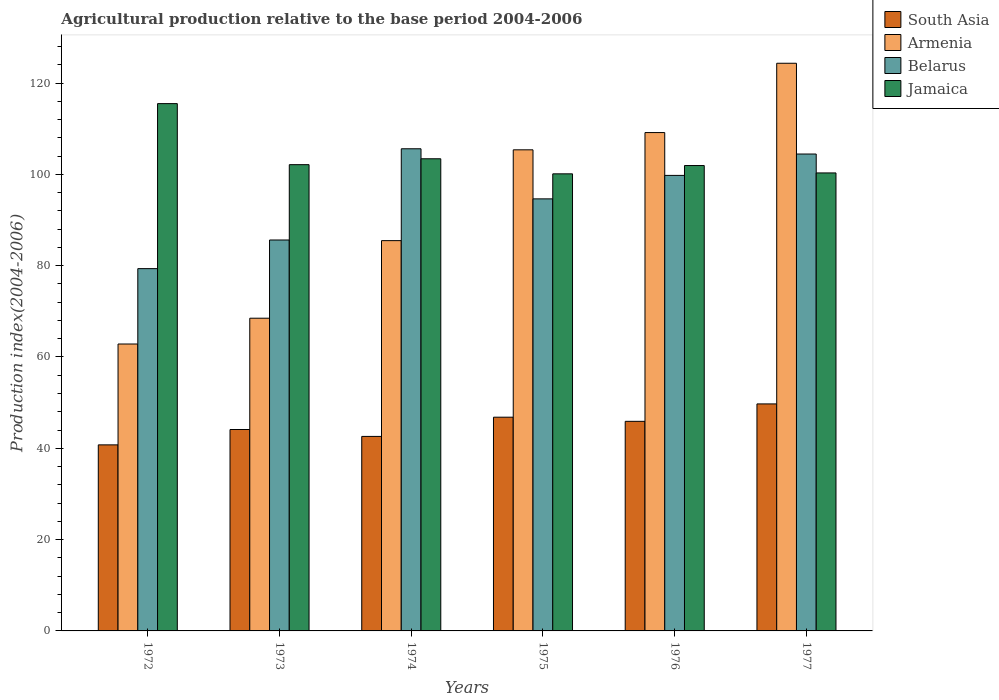How many groups of bars are there?
Offer a terse response. 6. Are the number of bars on each tick of the X-axis equal?
Provide a short and direct response. Yes. How many bars are there on the 3rd tick from the left?
Ensure brevity in your answer.  4. What is the label of the 4th group of bars from the left?
Offer a terse response. 1975. In how many cases, is the number of bars for a given year not equal to the number of legend labels?
Your answer should be compact. 0. What is the agricultural production index in South Asia in 1976?
Provide a short and direct response. 45.9. Across all years, what is the maximum agricultural production index in Belarus?
Offer a terse response. 105.6. Across all years, what is the minimum agricultural production index in Belarus?
Your answer should be very brief. 79.35. In which year was the agricultural production index in Armenia minimum?
Offer a terse response. 1972. What is the total agricultural production index in Belarus in the graph?
Offer a terse response. 569.42. What is the difference between the agricultural production index in Jamaica in 1974 and that in 1975?
Your response must be concise. 3.3. What is the difference between the agricultural production index in Belarus in 1975 and the agricultural production index in Armenia in 1977?
Offer a very short reply. -29.7. What is the average agricultural production index in South Asia per year?
Keep it short and to the point. 44.98. In the year 1977, what is the difference between the agricultural production index in Armenia and agricultural production index in South Asia?
Offer a very short reply. 74.61. In how many years, is the agricultural production index in South Asia greater than 92?
Ensure brevity in your answer.  0. What is the ratio of the agricultural production index in South Asia in 1974 to that in 1975?
Offer a terse response. 0.91. Is the agricultural production index in Belarus in 1972 less than that in 1976?
Provide a short and direct response. Yes. Is the difference between the agricultural production index in Armenia in 1974 and 1976 greater than the difference between the agricultural production index in South Asia in 1974 and 1976?
Provide a succinct answer. No. What is the difference between the highest and the second highest agricultural production index in Armenia?
Your answer should be compact. 15.18. What is the difference between the highest and the lowest agricultural production index in Jamaica?
Offer a very short reply. 15.38. In how many years, is the agricultural production index in Belarus greater than the average agricultural production index in Belarus taken over all years?
Keep it short and to the point. 3. Is the sum of the agricultural production index in Jamaica in 1976 and 1977 greater than the maximum agricultural production index in Armenia across all years?
Your answer should be compact. Yes. What does the 2nd bar from the left in 1972 represents?
Make the answer very short. Armenia. What does the 4th bar from the right in 1976 represents?
Make the answer very short. South Asia. Are all the bars in the graph horizontal?
Your response must be concise. No. Does the graph contain any zero values?
Your response must be concise. No. How many legend labels are there?
Give a very brief answer. 4. What is the title of the graph?
Ensure brevity in your answer.  Agricultural production relative to the base period 2004-2006. Does "Albania" appear as one of the legend labels in the graph?
Your response must be concise. No. What is the label or title of the X-axis?
Make the answer very short. Years. What is the label or title of the Y-axis?
Make the answer very short. Production index(2004-2006). What is the Production index(2004-2006) of South Asia in 1972?
Provide a succinct answer. 40.75. What is the Production index(2004-2006) of Armenia in 1972?
Provide a short and direct response. 62.84. What is the Production index(2004-2006) in Belarus in 1972?
Give a very brief answer. 79.35. What is the Production index(2004-2006) in Jamaica in 1972?
Your answer should be compact. 115.49. What is the Production index(2004-2006) in South Asia in 1973?
Offer a terse response. 44.12. What is the Production index(2004-2006) in Armenia in 1973?
Offer a terse response. 68.49. What is the Production index(2004-2006) of Belarus in 1973?
Keep it short and to the point. 85.62. What is the Production index(2004-2006) in Jamaica in 1973?
Keep it short and to the point. 102.12. What is the Production index(2004-2006) in South Asia in 1974?
Your answer should be very brief. 42.6. What is the Production index(2004-2006) in Armenia in 1974?
Your answer should be compact. 85.48. What is the Production index(2004-2006) in Belarus in 1974?
Offer a very short reply. 105.6. What is the Production index(2004-2006) of Jamaica in 1974?
Your response must be concise. 103.41. What is the Production index(2004-2006) in South Asia in 1975?
Offer a very short reply. 46.81. What is the Production index(2004-2006) of Armenia in 1975?
Offer a very short reply. 105.37. What is the Production index(2004-2006) in Belarus in 1975?
Give a very brief answer. 94.63. What is the Production index(2004-2006) of Jamaica in 1975?
Your answer should be very brief. 100.11. What is the Production index(2004-2006) of South Asia in 1976?
Your response must be concise. 45.9. What is the Production index(2004-2006) of Armenia in 1976?
Your answer should be very brief. 109.15. What is the Production index(2004-2006) in Belarus in 1976?
Your answer should be very brief. 99.77. What is the Production index(2004-2006) of Jamaica in 1976?
Your answer should be very brief. 101.93. What is the Production index(2004-2006) in South Asia in 1977?
Provide a succinct answer. 49.72. What is the Production index(2004-2006) in Armenia in 1977?
Give a very brief answer. 124.33. What is the Production index(2004-2006) of Belarus in 1977?
Your response must be concise. 104.45. What is the Production index(2004-2006) of Jamaica in 1977?
Your response must be concise. 100.31. Across all years, what is the maximum Production index(2004-2006) in South Asia?
Your answer should be very brief. 49.72. Across all years, what is the maximum Production index(2004-2006) in Armenia?
Make the answer very short. 124.33. Across all years, what is the maximum Production index(2004-2006) in Belarus?
Make the answer very short. 105.6. Across all years, what is the maximum Production index(2004-2006) of Jamaica?
Provide a short and direct response. 115.49. Across all years, what is the minimum Production index(2004-2006) of South Asia?
Make the answer very short. 40.75. Across all years, what is the minimum Production index(2004-2006) in Armenia?
Offer a terse response. 62.84. Across all years, what is the minimum Production index(2004-2006) in Belarus?
Keep it short and to the point. 79.35. Across all years, what is the minimum Production index(2004-2006) in Jamaica?
Keep it short and to the point. 100.11. What is the total Production index(2004-2006) of South Asia in the graph?
Your response must be concise. 269.9. What is the total Production index(2004-2006) in Armenia in the graph?
Your answer should be very brief. 555.66. What is the total Production index(2004-2006) of Belarus in the graph?
Offer a very short reply. 569.42. What is the total Production index(2004-2006) of Jamaica in the graph?
Your answer should be compact. 623.37. What is the difference between the Production index(2004-2006) of South Asia in 1972 and that in 1973?
Provide a short and direct response. -3.37. What is the difference between the Production index(2004-2006) of Armenia in 1972 and that in 1973?
Provide a succinct answer. -5.65. What is the difference between the Production index(2004-2006) of Belarus in 1972 and that in 1973?
Keep it short and to the point. -6.27. What is the difference between the Production index(2004-2006) of Jamaica in 1972 and that in 1973?
Your response must be concise. 13.37. What is the difference between the Production index(2004-2006) in South Asia in 1972 and that in 1974?
Provide a short and direct response. -1.85. What is the difference between the Production index(2004-2006) of Armenia in 1972 and that in 1974?
Give a very brief answer. -22.64. What is the difference between the Production index(2004-2006) of Belarus in 1972 and that in 1974?
Your answer should be very brief. -26.25. What is the difference between the Production index(2004-2006) of Jamaica in 1972 and that in 1974?
Offer a terse response. 12.08. What is the difference between the Production index(2004-2006) of South Asia in 1972 and that in 1975?
Provide a short and direct response. -6.06. What is the difference between the Production index(2004-2006) in Armenia in 1972 and that in 1975?
Keep it short and to the point. -42.53. What is the difference between the Production index(2004-2006) in Belarus in 1972 and that in 1975?
Your response must be concise. -15.28. What is the difference between the Production index(2004-2006) of Jamaica in 1972 and that in 1975?
Your answer should be compact. 15.38. What is the difference between the Production index(2004-2006) in South Asia in 1972 and that in 1976?
Provide a short and direct response. -5.15. What is the difference between the Production index(2004-2006) of Armenia in 1972 and that in 1976?
Provide a succinct answer. -46.31. What is the difference between the Production index(2004-2006) in Belarus in 1972 and that in 1976?
Provide a short and direct response. -20.42. What is the difference between the Production index(2004-2006) of Jamaica in 1972 and that in 1976?
Your response must be concise. 13.56. What is the difference between the Production index(2004-2006) in South Asia in 1972 and that in 1977?
Provide a short and direct response. -8.97. What is the difference between the Production index(2004-2006) in Armenia in 1972 and that in 1977?
Provide a succinct answer. -61.49. What is the difference between the Production index(2004-2006) of Belarus in 1972 and that in 1977?
Your answer should be compact. -25.1. What is the difference between the Production index(2004-2006) in Jamaica in 1972 and that in 1977?
Ensure brevity in your answer.  15.18. What is the difference between the Production index(2004-2006) of South Asia in 1973 and that in 1974?
Your response must be concise. 1.51. What is the difference between the Production index(2004-2006) in Armenia in 1973 and that in 1974?
Your response must be concise. -16.99. What is the difference between the Production index(2004-2006) of Belarus in 1973 and that in 1974?
Keep it short and to the point. -19.98. What is the difference between the Production index(2004-2006) in Jamaica in 1973 and that in 1974?
Make the answer very short. -1.29. What is the difference between the Production index(2004-2006) of South Asia in 1973 and that in 1975?
Keep it short and to the point. -2.69. What is the difference between the Production index(2004-2006) of Armenia in 1973 and that in 1975?
Your answer should be compact. -36.88. What is the difference between the Production index(2004-2006) in Belarus in 1973 and that in 1975?
Provide a succinct answer. -9.01. What is the difference between the Production index(2004-2006) of Jamaica in 1973 and that in 1975?
Provide a short and direct response. 2.01. What is the difference between the Production index(2004-2006) in South Asia in 1973 and that in 1976?
Provide a succinct answer. -1.79. What is the difference between the Production index(2004-2006) in Armenia in 1973 and that in 1976?
Provide a succinct answer. -40.66. What is the difference between the Production index(2004-2006) of Belarus in 1973 and that in 1976?
Offer a very short reply. -14.15. What is the difference between the Production index(2004-2006) in Jamaica in 1973 and that in 1976?
Your answer should be very brief. 0.19. What is the difference between the Production index(2004-2006) of South Asia in 1973 and that in 1977?
Provide a succinct answer. -5.6. What is the difference between the Production index(2004-2006) in Armenia in 1973 and that in 1977?
Provide a succinct answer. -55.84. What is the difference between the Production index(2004-2006) of Belarus in 1973 and that in 1977?
Offer a terse response. -18.83. What is the difference between the Production index(2004-2006) in Jamaica in 1973 and that in 1977?
Provide a succinct answer. 1.81. What is the difference between the Production index(2004-2006) of South Asia in 1974 and that in 1975?
Ensure brevity in your answer.  -4.21. What is the difference between the Production index(2004-2006) of Armenia in 1974 and that in 1975?
Offer a terse response. -19.89. What is the difference between the Production index(2004-2006) in Belarus in 1974 and that in 1975?
Offer a very short reply. 10.97. What is the difference between the Production index(2004-2006) in South Asia in 1974 and that in 1976?
Ensure brevity in your answer.  -3.3. What is the difference between the Production index(2004-2006) of Armenia in 1974 and that in 1976?
Provide a succinct answer. -23.67. What is the difference between the Production index(2004-2006) of Belarus in 1974 and that in 1976?
Offer a very short reply. 5.83. What is the difference between the Production index(2004-2006) in Jamaica in 1974 and that in 1976?
Provide a short and direct response. 1.48. What is the difference between the Production index(2004-2006) of South Asia in 1974 and that in 1977?
Offer a terse response. -7.12. What is the difference between the Production index(2004-2006) in Armenia in 1974 and that in 1977?
Provide a succinct answer. -38.85. What is the difference between the Production index(2004-2006) in Belarus in 1974 and that in 1977?
Offer a terse response. 1.15. What is the difference between the Production index(2004-2006) in Jamaica in 1974 and that in 1977?
Your response must be concise. 3.1. What is the difference between the Production index(2004-2006) in South Asia in 1975 and that in 1976?
Your response must be concise. 0.91. What is the difference between the Production index(2004-2006) of Armenia in 1975 and that in 1976?
Keep it short and to the point. -3.78. What is the difference between the Production index(2004-2006) in Belarus in 1975 and that in 1976?
Keep it short and to the point. -5.14. What is the difference between the Production index(2004-2006) in Jamaica in 1975 and that in 1976?
Give a very brief answer. -1.82. What is the difference between the Production index(2004-2006) in South Asia in 1975 and that in 1977?
Provide a succinct answer. -2.91. What is the difference between the Production index(2004-2006) in Armenia in 1975 and that in 1977?
Ensure brevity in your answer.  -18.96. What is the difference between the Production index(2004-2006) of Belarus in 1975 and that in 1977?
Your answer should be compact. -9.82. What is the difference between the Production index(2004-2006) of Jamaica in 1975 and that in 1977?
Offer a terse response. -0.2. What is the difference between the Production index(2004-2006) in South Asia in 1976 and that in 1977?
Make the answer very short. -3.82. What is the difference between the Production index(2004-2006) of Armenia in 1976 and that in 1977?
Provide a short and direct response. -15.18. What is the difference between the Production index(2004-2006) in Belarus in 1976 and that in 1977?
Provide a succinct answer. -4.68. What is the difference between the Production index(2004-2006) in Jamaica in 1976 and that in 1977?
Offer a terse response. 1.62. What is the difference between the Production index(2004-2006) of South Asia in 1972 and the Production index(2004-2006) of Armenia in 1973?
Provide a short and direct response. -27.74. What is the difference between the Production index(2004-2006) in South Asia in 1972 and the Production index(2004-2006) in Belarus in 1973?
Make the answer very short. -44.87. What is the difference between the Production index(2004-2006) of South Asia in 1972 and the Production index(2004-2006) of Jamaica in 1973?
Your answer should be compact. -61.37. What is the difference between the Production index(2004-2006) in Armenia in 1972 and the Production index(2004-2006) in Belarus in 1973?
Ensure brevity in your answer.  -22.78. What is the difference between the Production index(2004-2006) in Armenia in 1972 and the Production index(2004-2006) in Jamaica in 1973?
Ensure brevity in your answer.  -39.28. What is the difference between the Production index(2004-2006) in Belarus in 1972 and the Production index(2004-2006) in Jamaica in 1973?
Keep it short and to the point. -22.77. What is the difference between the Production index(2004-2006) of South Asia in 1972 and the Production index(2004-2006) of Armenia in 1974?
Your answer should be very brief. -44.73. What is the difference between the Production index(2004-2006) of South Asia in 1972 and the Production index(2004-2006) of Belarus in 1974?
Your answer should be very brief. -64.85. What is the difference between the Production index(2004-2006) of South Asia in 1972 and the Production index(2004-2006) of Jamaica in 1974?
Your response must be concise. -62.66. What is the difference between the Production index(2004-2006) of Armenia in 1972 and the Production index(2004-2006) of Belarus in 1974?
Offer a terse response. -42.76. What is the difference between the Production index(2004-2006) in Armenia in 1972 and the Production index(2004-2006) in Jamaica in 1974?
Offer a terse response. -40.57. What is the difference between the Production index(2004-2006) of Belarus in 1972 and the Production index(2004-2006) of Jamaica in 1974?
Offer a very short reply. -24.06. What is the difference between the Production index(2004-2006) in South Asia in 1972 and the Production index(2004-2006) in Armenia in 1975?
Your answer should be very brief. -64.62. What is the difference between the Production index(2004-2006) in South Asia in 1972 and the Production index(2004-2006) in Belarus in 1975?
Keep it short and to the point. -53.88. What is the difference between the Production index(2004-2006) in South Asia in 1972 and the Production index(2004-2006) in Jamaica in 1975?
Offer a very short reply. -59.36. What is the difference between the Production index(2004-2006) of Armenia in 1972 and the Production index(2004-2006) of Belarus in 1975?
Provide a succinct answer. -31.79. What is the difference between the Production index(2004-2006) of Armenia in 1972 and the Production index(2004-2006) of Jamaica in 1975?
Provide a short and direct response. -37.27. What is the difference between the Production index(2004-2006) in Belarus in 1972 and the Production index(2004-2006) in Jamaica in 1975?
Provide a succinct answer. -20.76. What is the difference between the Production index(2004-2006) in South Asia in 1972 and the Production index(2004-2006) in Armenia in 1976?
Your response must be concise. -68.4. What is the difference between the Production index(2004-2006) in South Asia in 1972 and the Production index(2004-2006) in Belarus in 1976?
Give a very brief answer. -59.02. What is the difference between the Production index(2004-2006) of South Asia in 1972 and the Production index(2004-2006) of Jamaica in 1976?
Offer a very short reply. -61.18. What is the difference between the Production index(2004-2006) in Armenia in 1972 and the Production index(2004-2006) in Belarus in 1976?
Offer a very short reply. -36.93. What is the difference between the Production index(2004-2006) in Armenia in 1972 and the Production index(2004-2006) in Jamaica in 1976?
Offer a terse response. -39.09. What is the difference between the Production index(2004-2006) of Belarus in 1972 and the Production index(2004-2006) of Jamaica in 1976?
Make the answer very short. -22.58. What is the difference between the Production index(2004-2006) of South Asia in 1972 and the Production index(2004-2006) of Armenia in 1977?
Your answer should be compact. -83.58. What is the difference between the Production index(2004-2006) in South Asia in 1972 and the Production index(2004-2006) in Belarus in 1977?
Provide a succinct answer. -63.7. What is the difference between the Production index(2004-2006) of South Asia in 1972 and the Production index(2004-2006) of Jamaica in 1977?
Your answer should be very brief. -59.56. What is the difference between the Production index(2004-2006) of Armenia in 1972 and the Production index(2004-2006) of Belarus in 1977?
Make the answer very short. -41.61. What is the difference between the Production index(2004-2006) in Armenia in 1972 and the Production index(2004-2006) in Jamaica in 1977?
Make the answer very short. -37.47. What is the difference between the Production index(2004-2006) in Belarus in 1972 and the Production index(2004-2006) in Jamaica in 1977?
Your answer should be compact. -20.96. What is the difference between the Production index(2004-2006) of South Asia in 1973 and the Production index(2004-2006) of Armenia in 1974?
Offer a terse response. -41.36. What is the difference between the Production index(2004-2006) in South Asia in 1973 and the Production index(2004-2006) in Belarus in 1974?
Offer a very short reply. -61.48. What is the difference between the Production index(2004-2006) in South Asia in 1973 and the Production index(2004-2006) in Jamaica in 1974?
Ensure brevity in your answer.  -59.29. What is the difference between the Production index(2004-2006) of Armenia in 1973 and the Production index(2004-2006) of Belarus in 1974?
Offer a terse response. -37.11. What is the difference between the Production index(2004-2006) in Armenia in 1973 and the Production index(2004-2006) in Jamaica in 1974?
Your response must be concise. -34.92. What is the difference between the Production index(2004-2006) of Belarus in 1973 and the Production index(2004-2006) of Jamaica in 1974?
Keep it short and to the point. -17.79. What is the difference between the Production index(2004-2006) in South Asia in 1973 and the Production index(2004-2006) in Armenia in 1975?
Your answer should be compact. -61.25. What is the difference between the Production index(2004-2006) in South Asia in 1973 and the Production index(2004-2006) in Belarus in 1975?
Make the answer very short. -50.51. What is the difference between the Production index(2004-2006) of South Asia in 1973 and the Production index(2004-2006) of Jamaica in 1975?
Ensure brevity in your answer.  -55.99. What is the difference between the Production index(2004-2006) of Armenia in 1973 and the Production index(2004-2006) of Belarus in 1975?
Ensure brevity in your answer.  -26.14. What is the difference between the Production index(2004-2006) of Armenia in 1973 and the Production index(2004-2006) of Jamaica in 1975?
Offer a very short reply. -31.62. What is the difference between the Production index(2004-2006) of Belarus in 1973 and the Production index(2004-2006) of Jamaica in 1975?
Provide a short and direct response. -14.49. What is the difference between the Production index(2004-2006) in South Asia in 1973 and the Production index(2004-2006) in Armenia in 1976?
Make the answer very short. -65.03. What is the difference between the Production index(2004-2006) of South Asia in 1973 and the Production index(2004-2006) of Belarus in 1976?
Provide a short and direct response. -55.65. What is the difference between the Production index(2004-2006) in South Asia in 1973 and the Production index(2004-2006) in Jamaica in 1976?
Offer a very short reply. -57.81. What is the difference between the Production index(2004-2006) of Armenia in 1973 and the Production index(2004-2006) of Belarus in 1976?
Offer a terse response. -31.28. What is the difference between the Production index(2004-2006) in Armenia in 1973 and the Production index(2004-2006) in Jamaica in 1976?
Offer a very short reply. -33.44. What is the difference between the Production index(2004-2006) in Belarus in 1973 and the Production index(2004-2006) in Jamaica in 1976?
Your answer should be very brief. -16.31. What is the difference between the Production index(2004-2006) in South Asia in 1973 and the Production index(2004-2006) in Armenia in 1977?
Offer a terse response. -80.21. What is the difference between the Production index(2004-2006) in South Asia in 1973 and the Production index(2004-2006) in Belarus in 1977?
Your answer should be very brief. -60.33. What is the difference between the Production index(2004-2006) of South Asia in 1973 and the Production index(2004-2006) of Jamaica in 1977?
Provide a short and direct response. -56.19. What is the difference between the Production index(2004-2006) in Armenia in 1973 and the Production index(2004-2006) in Belarus in 1977?
Your answer should be compact. -35.96. What is the difference between the Production index(2004-2006) of Armenia in 1973 and the Production index(2004-2006) of Jamaica in 1977?
Keep it short and to the point. -31.82. What is the difference between the Production index(2004-2006) in Belarus in 1973 and the Production index(2004-2006) in Jamaica in 1977?
Your answer should be very brief. -14.69. What is the difference between the Production index(2004-2006) in South Asia in 1974 and the Production index(2004-2006) in Armenia in 1975?
Provide a succinct answer. -62.77. What is the difference between the Production index(2004-2006) in South Asia in 1974 and the Production index(2004-2006) in Belarus in 1975?
Keep it short and to the point. -52.03. What is the difference between the Production index(2004-2006) in South Asia in 1974 and the Production index(2004-2006) in Jamaica in 1975?
Keep it short and to the point. -57.51. What is the difference between the Production index(2004-2006) in Armenia in 1974 and the Production index(2004-2006) in Belarus in 1975?
Your answer should be compact. -9.15. What is the difference between the Production index(2004-2006) in Armenia in 1974 and the Production index(2004-2006) in Jamaica in 1975?
Offer a very short reply. -14.63. What is the difference between the Production index(2004-2006) in Belarus in 1974 and the Production index(2004-2006) in Jamaica in 1975?
Provide a short and direct response. 5.49. What is the difference between the Production index(2004-2006) of South Asia in 1974 and the Production index(2004-2006) of Armenia in 1976?
Offer a very short reply. -66.55. What is the difference between the Production index(2004-2006) in South Asia in 1974 and the Production index(2004-2006) in Belarus in 1976?
Your answer should be very brief. -57.17. What is the difference between the Production index(2004-2006) in South Asia in 1974 and the Production index(2004-2006) in Jamaica in 1976?
Your answer should be compact. -59.33. What is the difference between the Production index(2004-2006) in Armenia in 1974 and the Production index(2004-2006) in Belarus in 1976?
Offer a very short reply. -14.29. What is the difference between the Production index(2004-2006) of Armenia in 1974 and the Production index(2004-2006) of Jamaica in 1976?
Offer a terse response. -16.45. What is the difference between the Production index(2004-2006) in Belarus in 1974 and the Production index(2004-2006) in Jamaica in 1976?
Offer a terse response. 3.67. What is the difference between the Production index(2004-2006) in South Asia in 1974 and the Production index(2004-2006) in Armenia in 1977?
Your response must be concise. -81.73. What is the difference between the Production index(2004-2006) of South Asia in 1974 and the Production index(2004-2006) of Belarus in 1977?
Make the answer very short. -61.85. What is the difference between the Production index(2004-2006) of South Asia in 1974 and the Production index(2004-2006) of Jamaica in 1977?
Offer a very short reply. -57.71. What is the difference between the Production index(2004-2006) in Armenia in 1974 and the Production index(2004-2006) in Belarus in 1977?
Ensure brevity in your answer.  -18.97. What is the difference between the Production index(2004-2006) in Armenia in 1974 and the Production index(2004-2006) in Jamaica in 1977?
Offer a very short reply. -14.83. What is the difference between the Production index(2004-2006) of Belarus in 1974 and the Production index(2004-2006) of Jamaica in 1977?
Make the answer very short. 5.29. What is the difference between the Production index(2004-2006) of South Asia in 1975 and the Production index(2004-2006) of Armenia in 1976?
Offer a terse response. -62.34. What is the difference between the Production index(2004-2006) in South Asia in 1975 and the Production index(2004-2006) in Belarus in 1976?
Give a very brief answer. -52.96. What is the difference between the Production index(2004-2006) of South Asia in 1975 and the Production index(2004-2006) of Jamaica in 1976?
Your response must be concise. -55.12. What is the difference between the Production index(2004-2006) of Armenia in 1975 and the Production index(2004-2006) of Belarus in 1976?
Your answer should be very brief. 5.6. What is the difference between the Production index(2004-2006) of Armenia in 1975 and the Production index(2004-2006) of Jamaica in 1976?
Offer a very short reply. 3.44. What is the difference between the Production index(2004-2006) of Belarus in 1975 and the Production index(2004-2006) of Jamaica in 1976?
Keep it short and to the point. -7.3. What is the difference between the Production index(2004-2006) in South Asia in 1975 and the Production index(2004-2006) in Armenia in 1977?
Offer a terse response. -77.52. What is the difference between the Production index(2004-2006) in South Asia in 1975 and the Production index(2004-2006) in Belarus in 1977?
Make the answer very short. -57.64. What is the difference between the Production index(2004-2006) of South Asia in 1975 and the Production index(2004-2006) of Jamaica in 1977?
Provide a short and direct response. -53.5. What is the difference between the Production index(2004-2006) of Armenia in 1975 and the Production index(2004-2006) of Jamaica in 1977?
Your response must be concise. 5.06. What is the difference between the Production index(2004-2006) of Belarus in 1975 and the Production index(2004-2006) of Jamaica in 1977?
Offer a very short reply. -5.68. What is the difference between the Production index(2004-2006) in South Asia in 1976 and the Production index(2004-2006) in Armenia in 1977?
Provide a succinct answer. -78.43. What is the difference between the Production index(2004-2006) of South Asia in 1976 and the Production index(2004-2006) of Belarus in 1977?
Your answer should be very brief. -58.55. What is the difference between the Production index(2004-2006) of South Asia in 1976 and the Production index(2004-2006) of Jamaica in 1977?
Keep it short and to the point. -54.41. What is the difference between the Production index(2004-2006) of Armenia in 1976 and the Production index(2004-2006) of Belarus in 1977?
Make the answer very short. 4.7. What is the difference between the Production index(2004-2006) of Armenia in 1976 and the Production index(2004-2006) of Jamaica in 1977?
Offer a terse response. 8.84. What is the difference between the Production index(2004-2006) of Belarus in 1976 and the Production index(2004-2006) of Jamaica in 1977?
Make the answer very short. -0.54. What is the average Production index(2004-2006) in South Asia per year?
Keep it short and to the point. 44.98. What is the average Production index(2004-2006) in Armenia per year?
Give a very brief answer. 92.61. What is the average Production index(2004-2006) of Belarus per year?
Your response must be concise. 94.9. What is the average Production index(2004-2006) in Jamaica per year?
Keep it short and to the point. 103.89. In the year 1972, what is the difference between the Production index(2004-2006) in South Asia and Production index(2004-2006) in Armenia?
Provide a short and direct response. -22.09. In the year 1972, what is the difference between the Production index(2004-2006) in South Asia and Production index(2004-2006) in Belarus?
Your answer should be compact. -38.6. In the year 1972, what is the difference between the Production index(2004-2006) of South Asia and Production index(2004-2006) of Jamaica?
Offer a terse response. -74.74. In the year 1972, what is the difference between the Production index(2004-2006) of Armenia and Production index(2004-2006) of Belarus?
Your answer should be very brief. -16.51. In the year 1972, what is the difference between the Production index(2004-2006) in Armenia and Production index(2004-2006) in Jamaica?
Offer a very short reply. -52.65. In the year 1972, what is the difference between the Production index(2004-2006) in Belarus and Production index(2004-2006) in Jamaica?
Keep it short and to the point. -36.14. In the year 1973, what is the difference between the Production index(2004-2006) in South Asia and Production index(2004-2006) in Armenia?
Ensure brevity in your answer.  -24.37. In the year 1973, what is the difference between the Production index(2004-2006) in South Asia and Production index(2004-2006) in Belarus?
Give a very brief answer. -41.5. In the year 1973, what is the difference between the Production index(2004-2006) of South Asia and Production index(2004-2006) of Jamaica?
Make the answer very short. -58. In the year 1973, what is the difference between the Production index(2004-2006) of Armenia and Production index(2004-2006) of Belarus?
Your response must be concise. -17.13. In the year 1973, what is the difference between the Production index(2004-2006) of Armenia and Production index(2004-2006) of Jamaica?
Ensure brevity in your answer.  -33.63. In the year 1973, what is the difference between the Production index(2004-2006) of Belarus and Production index(2004-2006) of Jamaica?
Keep it short and to the point. -16.5. In the year 1974, what is the difference between the Production index(2004-2006) of South Asia and Production index(2004-2006) of Armenia?
Your answer should be very brief. -42.88. In the year 1974, what is the difference between the Production index(2004-2006) of South Asia and Production index(2004-2006) of Belarus?
Give a very brief answer. -63. In the year 1974, what is the difference between the Production index(2004-2006) of South Asia and Production index(2004-2006) of Jamaica?
Ensure brevity in your answer.  -60.81. In the year 1974, what is the difference between the Production index(2004-2006) of Armenia and Production index(2004-2006) of Belarus?
Ensure brevity in your answer.  -20.12. In the year 1974, what is the difference between the Production index(2004-2006) of Armenia and Production index(2004-2006) of Jamaica?
Keep it short and to the point. -17.93. In the year 1974, what is the difference between the Production index(2004-2006) of Belarus and Production index(2004-2006) of Jamaica?
Offer a terse response. 2.19. In the year 1975, what is the difference between the Production index(2004-2006) in South Asia and Production index(2004-2006) in Armenia?
Your response must be concise. -58.56. In the year 1975, what is the difference between the Production index(2004-2006) in South Asia and Production index(2004-2006) in Belarus?
Offer a very short reply. -47.82. In the year 1975, what is the difference between the Production index(2004-2006) in South Asia and Production index(2004-2006) in Jamaica?
Offer a very short reply. -53.3. In the year 1975, what is the difference between the Production index(2004-2006) of Armenia and Production index(2004-2006) of Belarus?
Your response must be concise. 10.74. In the year 1975, what is the difference between the Production index(2004-2006) of Armenia and Production index(2004-2006) of Jamaica?
Give a very brief answer. 5.26. In the year 1975, what is the difference between the Production index(2004-2006) of Belarus and Production index(2004-2006) of Jamaica?
Provide a short and direct response. -5.48. In the year 1976, what is the difference between the Production index(2004-2006) in South Asia and Production index(2004-2006) in Armenia?
Offer a very short reply. -63.25. In the year 1976, what is the difference between the Production index(2004-2006) in South Asia and Production index(2004-2006) in Belarus?
Make the answer very short. -53.87. In the year 1976, what is the difference between the Production index(2004-2006) in South Asia and Production index(2004-2006) in Jamaica?
Your response must be concise. -56.03. In the year 1976, what is the difference between the Production index(2004-2006) in Armenia and Production index(2004-2006) in Belarus?
Provide a succinct answer. 9.38. In the year 1976, what is the difference between the Production index(2004-2006) in Armenia and Production index(2004-2006) in Jamaica?
Provide a succinct answer. 7.22. In the year 1976, what is the difference between the Production index(2004-2006) of Belarus and Production index(2004-2006) of Jamaica?
Your answer should be very brief. -2.16. In the year 1977, what is the difference between the Production index(2004-2006) of South Asia and Production index(2004-2006) of Armenia?
Ensure brevity in your answer.  -74.61. In the year 1977, what is the difference between the Production index(2004-2006) in South Asia and Production index(2004-2006) in Belarus?
Make the answer very short. -54.73. In the year 1977, what is the difference between the Production index(2004-2006) of South Asia and Production index(2004-2006) of Jamaica?
Ensure brevity in your answer.  -50.59. In the year 1977, what is the difference between the Production index(2004-2006) in Armenia and Production index(2004-2006) in Belarus?
Your answer should be compact. 19.88. In the year 1977, what is the difference between the Production index(2004-2006) in Armenia and Production index(2004-2006) in Jamaica?
Provide a succinct answer. 24.02. In the year 1977, what is the difference between the Production index(2004-2006) of Belarus and Production index(2004-2006) of Jamaica?
Make the answer very short. 4.14. What is the ratio of the Production index(2004-2006) in South Asia in 1972 to that in 1973?
Ensure brevity in your answer.  0.92. What is the ratio of the Production index(2004-2006) in Armenia in 1972 to that in 1973?
Provide a succinct answer. 0.92. What is the ratio of the Production index(2004-2006) in Belarus in 1972 to that in 1973?
Make the answer very short. 0.93. What is the ratio of the Production index(2004-2006) in Jamaica in 1972 to that in 1973?
Ensure brevity in your answer.  1.13. What is the ratio of the Production index(2004-2006) of South Asia in 1972 to that in 1974?
Keep it short and to the point. 0.96. What is the ratio of the Production index(2004-2006) of Armenia in 1972 to that in 1974?
Your answer should be very brief. 0.74. What is the ratio of the Production index(2004-2006) of Belarus in 1972 to that in 1974?
Give a very brief answer. 0.75. What is the ratio of the Production index(2004-2006) of Jamaica in 1972 to that in 1974?
Your answer should be compact. 1.12. What is the ratio of the Production index(2004-2006) in South Asia in 1972 to that in 1975?
Your answer should be very brief. 0.87. What is the ratio of the Production index(2004-2006) in Armenia in 1972 to that in 1975?
Your response must be concise. 0.6. What is the ratio of the Production index(2004-2006) of Belarus in 1972 to that in 1975?
Your answer should be very brief. 0.84. What is the ratio of the Production index(2004-2006) in Jamaica in 1972 to that in 1975?
Provide a succinct answer. 1.15. What is the ratio of the Production index(2004-2006) of South Asia in 1972 to that in 1976?
Ensure brevity in your answer.  0.89. What is the ratio of the Production index(2004-2006) of Armenia in 1972 to that in 1976?
Make the answer very short. 0.58. What is the ratio of the Production index(2004-2006) in Belarus in 1972 to that in 1976?
Provide a short and direct response. 0.8. What is the ratio of the Production index(2004-2006) of Jamaica in 1972 to that in 1976?
Provide a succinct answer. 1.13. What is the ratio of the Production index(2004-2006) in South Asia in 1972 to that in 1977?
Your answer should be compact. 0.82. What is the ratio of the Production index(2004-2006) in Armenia in 1972 to that in 1977?
Offer a very short reply. 0.51. What is the ratio of the Production index(2004-2006) of Belarus in 1972 to that in 1977?
Your answer should be very brief. 0.76. What is the ratio of the Production index(2004-2006) in Jamaica in 1972 to that in 1977?
Ensure brevity in your answer.  1.15. What is the ratio of the Production index(2004-2006) of South Asia in 1973 to that in 1974?
Make the answer very short. 1.04. What is the ratio of the Production index(2004-2006) in Armenia in 1973 to that in 1974?
Ensure brevity in your answer.  0.8. What is the ratio of the Production index(2004-2006) in Belarus in 1973 to that in 1974?
Offer a very short reply. 0.81. What is the ratio of the Production index(2004-2006) of Jamaica in 1973 to that in 1974?
Give a very brief answer. 0.99. What is the ratio of the Production index(2004-2006) in South Asia in 1973 to that in 1975?
Offer a very short reply. 0.94. What is the ratio of the Production index(2004-2006) in Armenia in 1973 to that in 1975?
Offer a very short reply. 0.65. What is the ratio of the Production index(2004-2006) in Belarus in 1973 to that in 1975?
Your response must be concise. 0.9. What is the ratio of the Production index(2004-2006) of Jamaica in 1973 to that in 1975?
Give a very brief answer. 1.02. What is the ratio of the Production index(2004-2006) of South Asia in 1973 to that in 1976?
Make the answer very short. 0.96. What is the ratio of the Production index(2004-2006) in Armenia in 1973 to that in 1976?
Offer a terse response. 0.63. What is the ratio of the Production index(2004-2006) of Belarus in 1973 to that in 1976?
Give a very brief answer. 0.86. What is the ratio of the Production index(2004-2006) of Jamaica in 1973 to that in 1976?
Provide a succinct answer. 1. What is the ratio of the Production index(2004-2006) of South Asia in 1973 to that in 1977?
Your answer should be very brief. 0.89. What is the ratio of the Production index(2004-2006) of Armenia in 1973 to that in 1977?
Your answer should be very brief. 0.55. What is the ratio of the Production index(2004-2006) in Belarus in 1973 to that in 1977?
Provide a succinct answer. 0.82. What is the ratio of the Production index(2004-2006) of South Asia in 1974 to that in 1975?
Ensure brevity in your answer.  0.91. What is the ratio of the Production index(2004-2006) in Armenia in 1974 to that in 1975?
Your answer should be very brief. 0.81. What is the ratio of the Production index(2004-2006) of Belarus in 1974 to that in 1975?
Make the answer very short. 1.12. What is the ratio of the Production index(2004-2006) in Jamaica in 1974 to that in 1975?
Offer a very short reply. 1.03. What is the ratio of the Production index(2004-2006) in South Asia in 1974 to that in 1976?
Your response must be concise. 0.93. What is the ratio of the Production index(2004-2006) of Armenia in 1974 to that in 1976?
Provide a short and direct response. 0.78. What is the ratio of the Production index(2004-2006) of Belarus in 1974 to that in 1976?
Keep it short and to the point. 1.06. What is the ratio of the Production index(2004-2006) of Jamaica in 1974 to that in 1976?
Offer a very short reply. 1.01. What is the ratio of the Production index(2004-2006) of South Asia in 1974 to that in 1977?
Offer a terse response. 0.86. What is the ratio of the Production index(2004-2006) of Armenia in 1974 to that in 1977?
Offer a very short reply. 0.69. What is the ratio of the Production index(2004-2006) in Jamaica in 1974 to that in 1977?
Your answer should be very brief. 1.03. What is the ratio of the Production index(2004-2006) in South Asia in 1975 to that in 1976?
Your answer should be compact. 1.02. What is the ratio of the Production index(2004-2006) of Armenia in 1975 to that in 1976?
Make the answer very short. 0.97. What is the ratio of the Production index(2004-2006) of Belarus in 1975 to that in 1976?
Provide a succinct answer. 0.95. What is the ratio of the Production index(2004-2006) of Jamaica in 1975 to that in 1976?
Your answer should be very brief. 0.98. What is the ratio of the Production index(2004-2006) in South Asia in 1975 to that in 1977?
Ensure brevity in your answer.  0.94. What is the ratio of the Production index(2004-2006) in Armenia in 1975 to that in 1977?
Your response must be concise. 0.85. What is the ratio of the Production index(2004-2006) in Belarus in 1975 to that in 1977?
Offer a very short reply. 0.91. What is the ratio of the Production index(2004-2006) of South Asia in 1976 to that in 1977?
Make the answer very short. 0.92. What is the ratio of the Production index(2004-2006) in Armenia in 1976 to that in 1977?
Your response must be concise. 0.88. What is the ratio of the Production index(2004-2006) in Belarus in 1976 to that in 1977?
Keep it short and to the point. 0.96. What is the ratio of the Production index(2004-2006) of Jamaica in 1976 to that in 1977?
Your answer should be very brief. 1.02. What is the difference between the highest and the second highest Production index(2004-2006) of South Asia?
Offer a terse response. 2.91. What is the difference between the highest and the second highest Production index(2004-2006) in Armenia?
Provide a short and direct response. 15.18. What is the difference between the highest and the second highest Production index(2004-2006) of Belarus?
Offer a very short reply. 1.15. What is the difference between the highest and the second highest Production index(2004-2006) of Jamaica?
Ensure brevity in your answer.  12.08. What is the difference between the highest and the lowest Production index(2004-2006) in South Asia?
Give a very brief answer. 8.97. What is the difference between the highest and the lowest Production index(2004-2006) in Armenia?
Ensure brevity in your answer.  61.49. What is the difference between the highest and the lowest Production index(2004-2006) in Belarus?
Keep it short and to the point. 26.25. What is the difference between the highest and the lowest Production index(2004-2006) in Jamaica?
Ensure brevity in your answer.  15.38. 